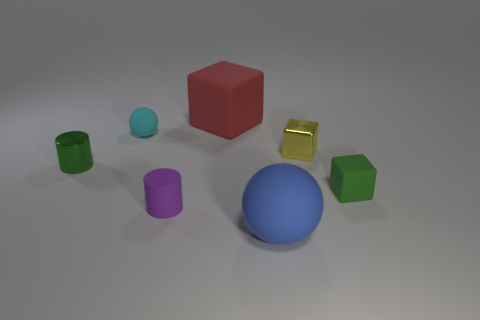There is a green metal object that is the same shape as the small purple matte object; what is its size?
Keep it short and to the point. Small. Is the number of small cylinders that are on the left side of the red block the same as the number of red things?
Your answer should be compact. No. Does the small matte object that is right of the yellow metal thing have the same shape as the green shiny object?
Provide a succinct answer. No. What shape is the blue object?
Ensure brevity in your answer.  Sphere. What material is the tiny green object left of the rubber block that is behind the small green object that is left of the small yellow shiny object?
Give a very brief answer. Metal. There is a small thing that is the same color as the shiny cylinder; what material is it?
Keep it short and to the point. Rubber. How many things are either small cyan rubber things or yellow things?
Make the answer very short. 2. Do the tiny cylinder that is in front of the small green rubber block and the big red thing have the same material?
Ensure brevity in your answer.  Yes. How many things are matte things in front of the small rubber cube or gray blocks?
Provide a succinct answer. 2. The small block that is made of the same material as the tiny purple cylinder is what color?
Provide a succinct answer. Green. 